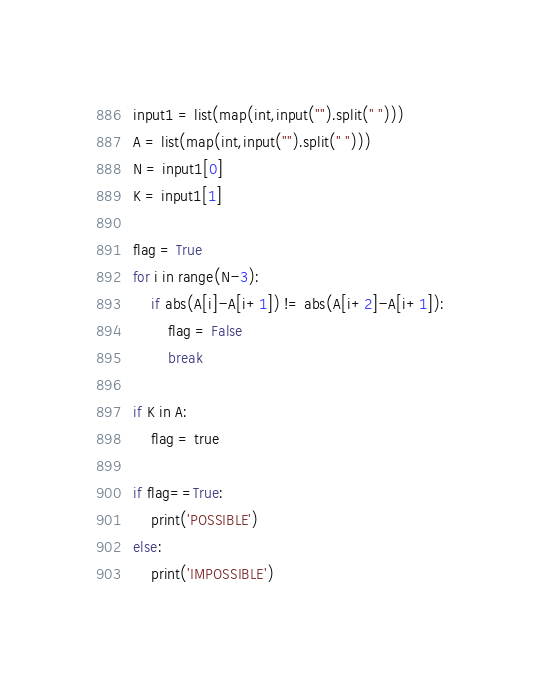<code> <loc_0><loc_0><loc_500><loc_500><_Python_>input1 = list(map(int,input("").split(" ")))
A = list(map(int,input("").split(" ")))
N = input1[0]
K = input1[1]

flag = True
for i in range(N-3):
	if abs(A[i]-A[i+1]) != abs(A[i+2]-A[i+1]):
		flag = False
		break

if K in A:
	flag = true

if flag==True:
	print('POSSIBLE')
else:
	print('IMPOSSIBLE')</code> 